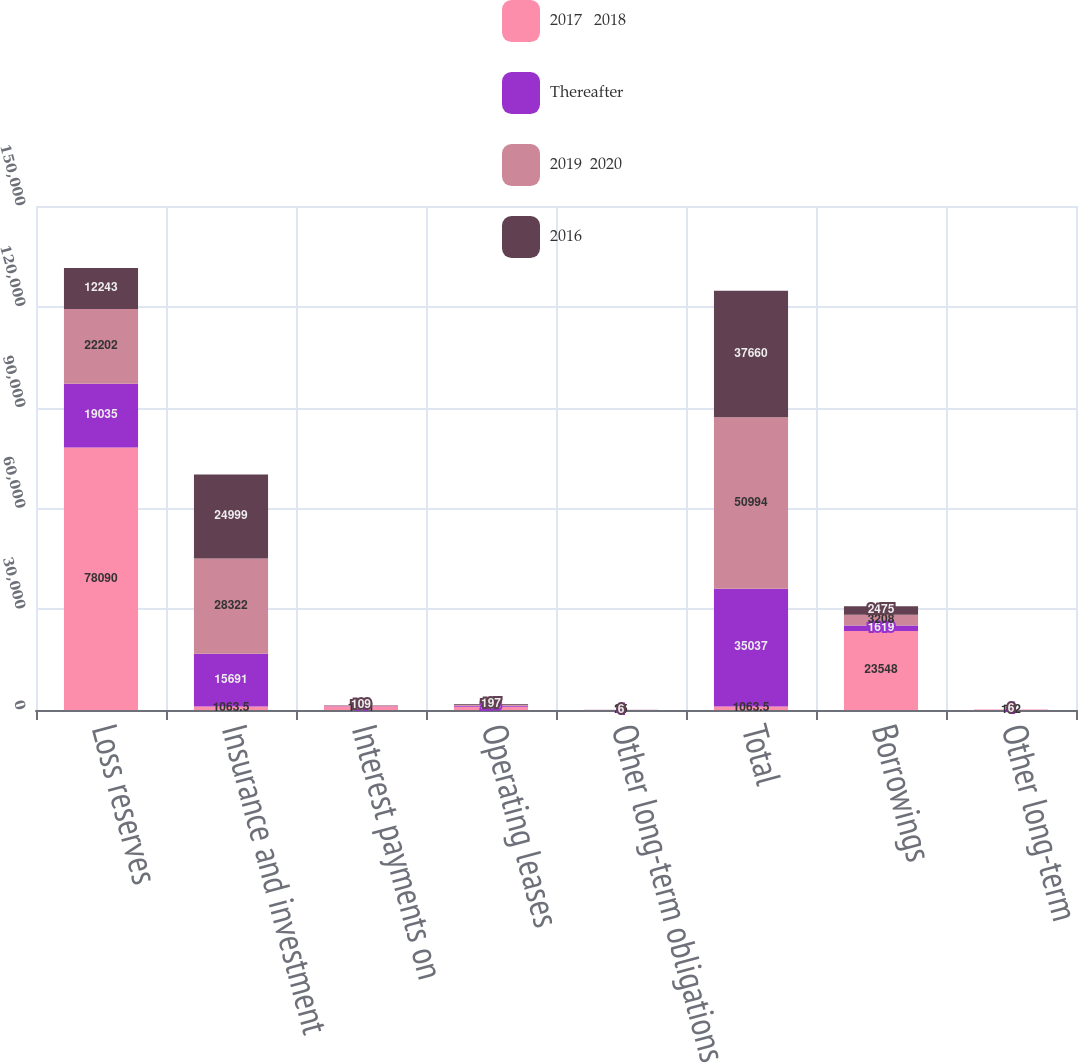<chart> <loc_0><loc_0><loc_500><loc_500><stacked_bar_chart><ecel><fcel>Loss reserves<fcel>Insurance and investment<fcel>Interest payments on<fcel>Operating leases<fcel>Other long-term obligations<fcel>Total<fcel>Borrowings<fcel>Other long-term<nl><fcel>2017   2018<fcel>78090<fcel>1063.5<fcel>1141<fcel>986<fcel>25<fcel>1063.5<fcel>23548<fcel>132<nl><fcel>Thereafter<fcel>19035<fcel>15691<fcel>54<fcel>253<fcel>4<fcel>35037<fcel>1619<fcel>4<nl><fcel>2019  2020<fcel>22202<fcel>28322<fcel>109<fcel>350<fcel>11<fcel>50994<fcel>3208<fcel>11<nl><fcel>2016<fcel>12243<fcel>24999<fcel>109<fcel>197<fcel>6<fcel>37660<fcel>2475<fcel>6<nl></chart> 